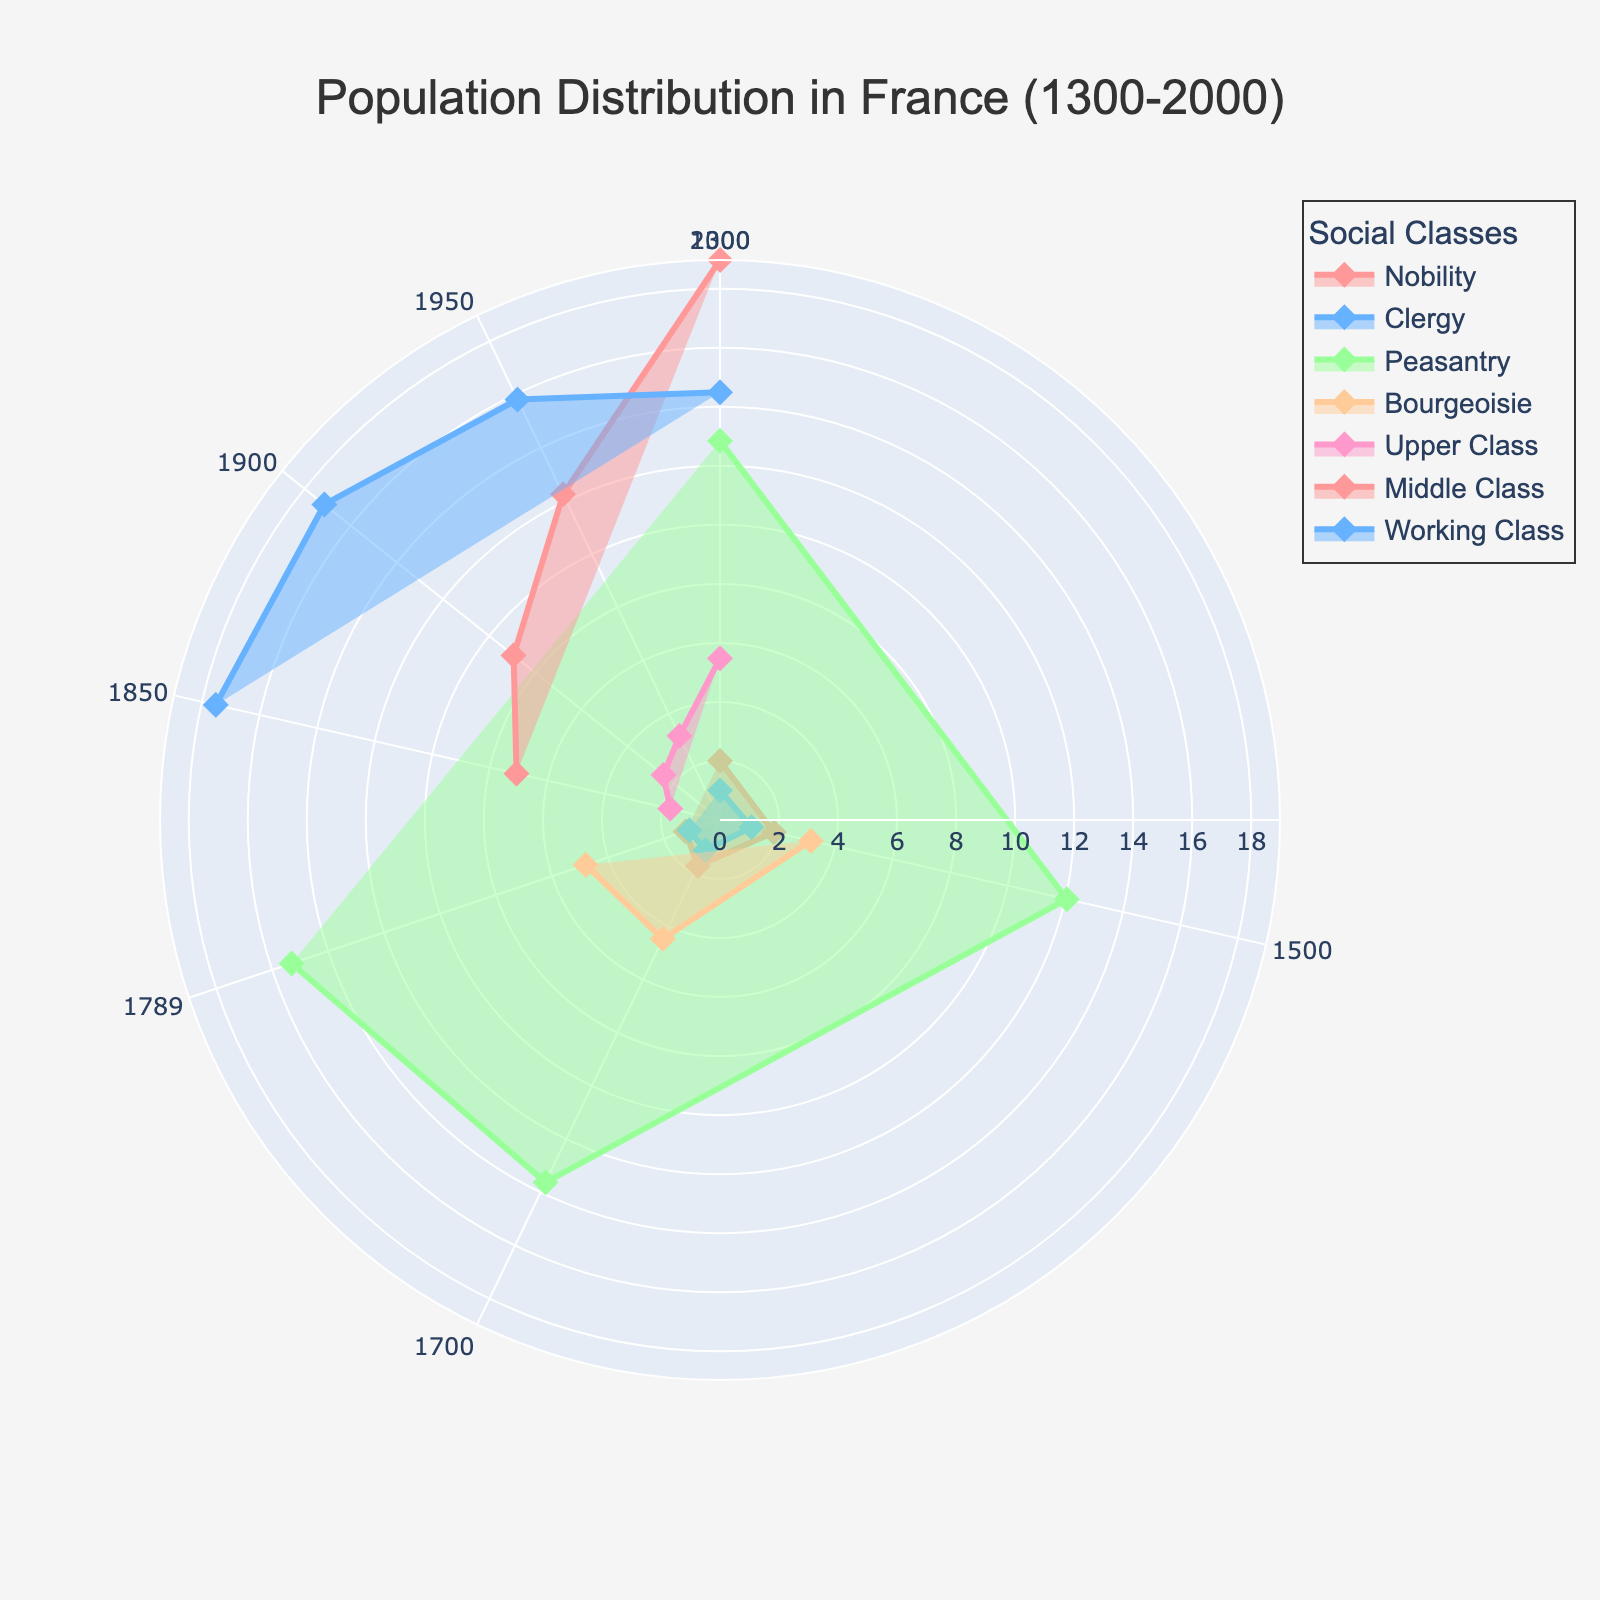What is the title of the figure? The title is usually found at the top of the figure. In this case, it is "Population Distribution in France (1300-2000)".
Answer: Population Distribution in France (1300-2000) Which social class had the largest population in 2000? By looking at the outermost layer (representing the latest year 2000), we can see the segment with the maximum radius. Here, it is the "Middle Class".
Answer: Middle Class How many social classes are represented in the figure? Different colors represent different social classes. By counting the number of unique colors, we can see there are five social classes: Nobility, Clergy, Peasantry, Bourgeoisie, and Upper/Middle/Working Class (post-1789 classes).
Answer: Five What are the radial distances used to denote the population size? Radial distances represent the square root of the population size divided by the minimum population size. This transformation is used to better compare different population sizes visually.
Answer: Square root of population size Which social class had the most consistent population size between 1300 and 2000? By examining the segments' shapes from the center to the edge, the "Clergy" class shows relatively little variation in radius compared to other social classes.
Answer: Clergy For which social class does the population peak occur last? The peak population is indicated by the largest radius. The "Middle Class" shows its peak in the year 2000, thereby it's the latest peak among all classes.
Answer: Middle Class What year had the highest total population across all classes? To find this, we need to sum the populations per year and compare. The year 2000 has the highest total population when summing all affected social classes.
Answer: 2000 In which year's transition did the "Bourgeoisie" class first appear in the fan chart? Visually inspect when the "Bourgeoisie" class segment becomes non-zero. This appears first in 1500.
Answer: 1500 Between which two years did the nobility's population halve approximately? Notice the notable reduction from 300,000 in 1700 to 150,000 in 1789, a clear halving trend that can be estimated visually from the radius change.
Answer: 1700 to 1789 How does the population of the working class in 1950 compare to that in 2000? Compare the radii for the working class in 1950 and 2000. The radius is smaller in 2000 indicating a reduced population.
Answer: Less in 2000 